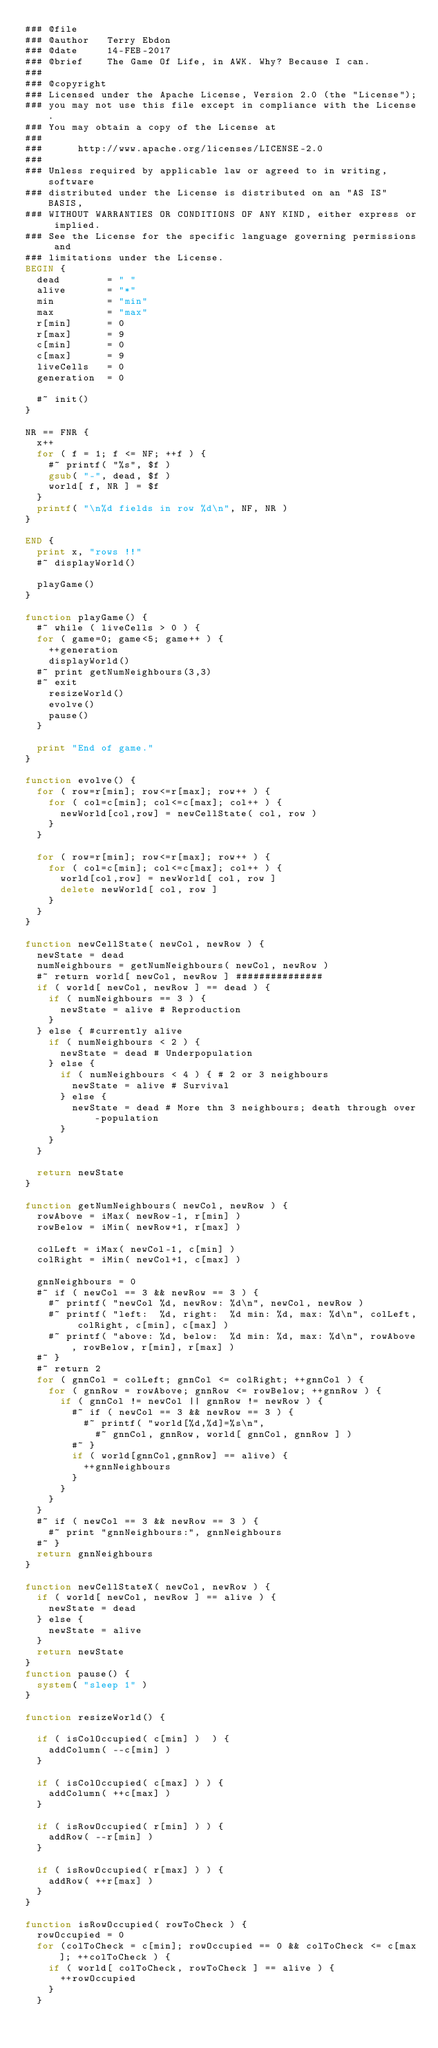Convert code to text. <code><loc_0><loc_0><loc_500><loc_500><_Awk_>### @file
### @author   Terry Ebdon
### @date     14-FEB-2017
### @brief		The Game Of Life, in AWK. Why? Because I can.
###
### @copyright
### Licensed under the Apache License, Version 2.0 (the "License");
### you may not use this file except in compliance with the License.
### You may obtain a copy of the License at
###
###      http://www.apache.org/licenses/LICENSE-2.0
###
### Unless required by applicable law or agreed to in writing, software
### distributed under the License is distributed on an "AS IS" BASIS,
### WITHOUT WARRANTIES OR CONDITIONS OF ANY KIND, either express or implied.
### See the License for the specific language governing permissions and
### limitations under the License.
BEGIN {
	dead 				= " "
	alive				= "*"
	min					= "min"
	max					= "max"
	r[min]			= 0
	r[max]			= 9
	c[min]			= 0
	c[max]			= 9
	liveCells		= 0
	generation	= 0

	#~ init()
}

NR == FNR {
	x++
	for ( f = 1; f <= NF; ++f ) {
		#~ printf( "%s", $f )
		gsub( "-", dead, $f )
		world[ f, NR ] = $f
	}
	printf( "\n%d fields in row %d\n", NF, NR )
}

END {
	print x, "rows !!"
	#~ displayWorld()

	playGame()
}

function playGame() {
	#~ while ( liveCells > 0 ) {
	for ( game=0; game<5; game++ ) {
		++generation
		displayWorld()
	#~ print getNumNeighbours(3,3)
	#~ exit
		resizeWorld()
		evolve()
		pause()
	}

	print "End of game."
}

function evolve() {
	for ( row=r[min]; row<=r[max]; row++ ) {
		for ( col=c[min]; col<=c[max]; col++ ) {
			newWorld[col,row] = newCellState( col, row )
		}
	}

	for ( row=r[min]; row<=r[max]; row++ ) {
		for ( col=c[min]; col<=c[max]; col++ ) {
			world[col,row] = newWorld[ col, row ]
			delete newWorld[ col, row ]
		}
	}
}

function newCellState( newCol, newRow ) {
	newState = dead
	numNeighbours = getNumNeighbours( newCol, newRow )
	#~ return world[ newCol, newRow ] ###############
	if ( world[ newCol, newRow ] == dead ) {
		if ( numNeighbours == 3 ) {
			newState = alive # Reproduction
		}
	} else { #currently alive
		if ( numNeighbours < 2 ) {
			newState = dead # Underpopulation
		} else {
			if ( numNeighbours < 4 ) { # 2 or 3 neighbours
				newState = alive # Survival
			} else {
				newState = dead # More thn 3 neighbours; death through over-population
			}
		}
	}

	return newState
}

function getNumNeighbours( newCol, newRow ) {
	rowAbove = iMax( newRow-1, r[min] )
	rowBelow = iMin( newRow+1, r[max] )

	colLeft = iMax( newCol-1, c[min] )
	colRight = iMin( newCol+1, c[max] )

	gnnNeighbours = 0
	#~ if ( newCol == 3 && newRow == 3 ) {
		#~ printf( "newCol %d, newRow: %d\n", newCol, newRow )
		#~ printf( "left:  %d, right:  %d min: %d, max: %d\n", colLeft, colRight, c[min], c[max] )
		#~ printf( "above: %d, below:  %d min: %d, max: %d\n", rowAbove, rowBelow, r[min], r[max] )
	#~ }
	#~ return 2
	for ( gnnCol = colLeft; gnnCol <= colRight; ++gnnCol ) {
		for ( gnnRow = rowAbove; gnnRow <= rowBelow; ++gnnRow ) {
			if ( gnnCol != newCol || gnnRow != newRow ) {
				#~ if ( newCol == 3 && newRow == 3 ) {
					#~ printf( "world[%d,%d]=%s\n",
						#~ gnnCol, gnnRow, world[ gnnCol, gnnRow ] )
				#~ }
				if ( world[gnnCol,gnnRow] == alive) {
					++gnnNeighbours
				}
			}
		}
	}
	#~ if ( newCol == 3 && newRow == 3 ) {
		#~ print "gnnNeighbours:", gnnNeighbours
	#~ }
	return gnnNeighbours
}

function newCellStateX( newCol, newRow ) {
	if ( world[ newCol, newRow ] == alive ) {
		newState = dead
	} else {
		newState = alive
	}
	return newState
}
function pause() {
	system( "sleep 1" )
}

function resizeWorld() {

	if ( isColOccupied( c[min] )  ) {
		addColumn( --c[min] )
	}

	if ( isColOccupied( c[max] ) ) {
		addColumn( ++c[max] )
	}

	if ( isRowOccupied( r[min] ) ) {
		addRow( --r[min] )
	}

	if ( isRowOccupied( r[max] ) ) {
		addRow( ++r[max] )
	}
}

function isRowOccupied( rowToCheck ) {
	rowOccupied = 0
	for (colToCheck = c[min]; rowOccupied == 0 && colToCheck <= c[max]; ++colToCheck ) {
		if ( world[ colToCheck, rowToCheck ] == alive ) {
			++rowOccupied
		}
	}</code> 